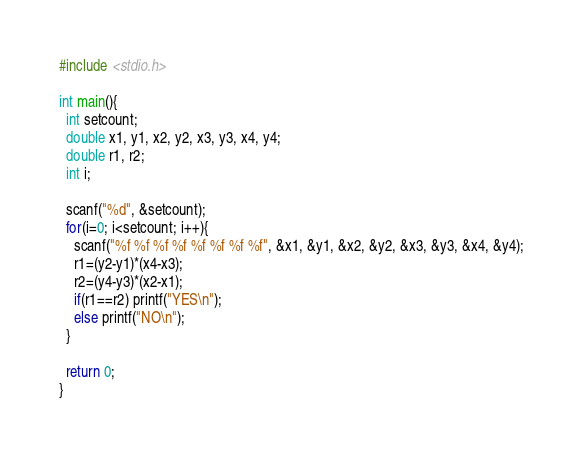Convert code to text. <code><loc_0><loc_0><loc_500><loc_500><_C_>#include <stdio.h>

int main(){
  int setcount;
  double x1, y1, x2, y2, x3, y3, x4, y4;
  double r1, r2;
  int i;

  scanf("%d", &setcount);
  for(i=0; i<setcount; i++){
    scanf("%f %f %f %f %f %f %f %f", &x1, &y1, &x2, &y2, &x3, &y3, &x4, &y4);
    r1=(y2-y1)*(x4-x3);
    r2=(y4-y3)*(x2-x1);
    if(r1==r2) printf("YES\n");
    else printf("NO\n");
  }

  return 0;
}</code> 